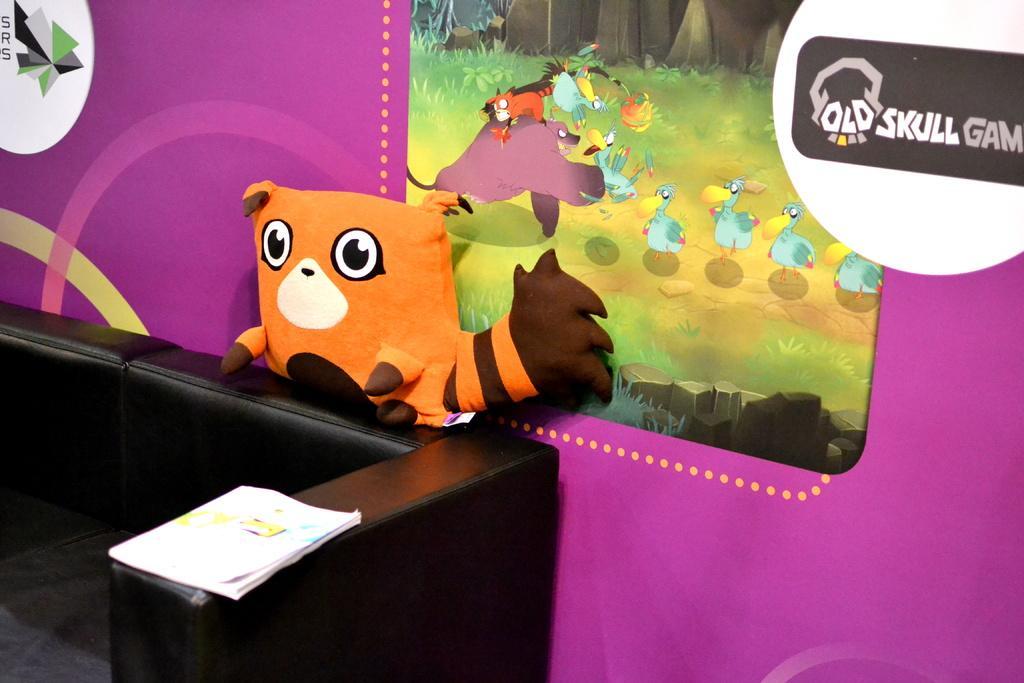Describe this image in one or two sentences. In this image I can see the black color couch. On the couch there are papers, brown and an orange color toy. In the background I can see the wall which is in colorful. I can also see the painting of birds and an animals on the wall. 